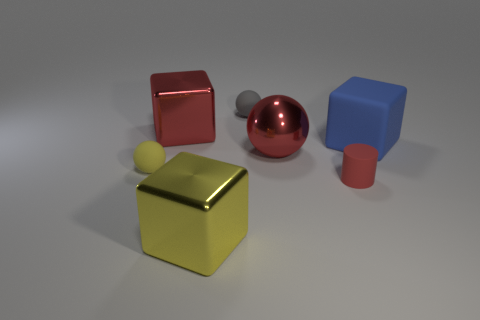How many things are tiny gray rubber balls or cubes to the right of the small cylinder?
Give a very brief answer. 2. What is the size of the red metallic thing that is in front of the large metallic thing that is to the left of the metal block in front of the large rubber cube?
Your answer should be very brief. Large. There is a blue block that is the same size as the red cube; what is its material?
Offer a very short reply. Rubber. Are there any yellow spheres of the same size as the matte cylinder?
Your answer should be compact. Yes. Do the red thing that is on the left side of the gray object and the red metallic sphere have the same size?
Ensure brevity in your answer.  Yes. There is a thing that is both in front of the tiny yellow matte object and right of the red ball; what is its shape?
Provide a short and direct response. Cylinder. Is the number of yellow objects that are in front of the tiny cylinder greater than the number of small rubber cubes?
Offer a terse response. Yes. What size is the other cube that is made of the same material as the yellow cube?
Make the answer very short. Large. How many big shiny blocks are the same color as the cylinder?
Your answer should be very brief. 1. There is a shiny object behind the big red metal ball; is it the same color as the tiny cylinder?
Offer a very short reply. Yes. 